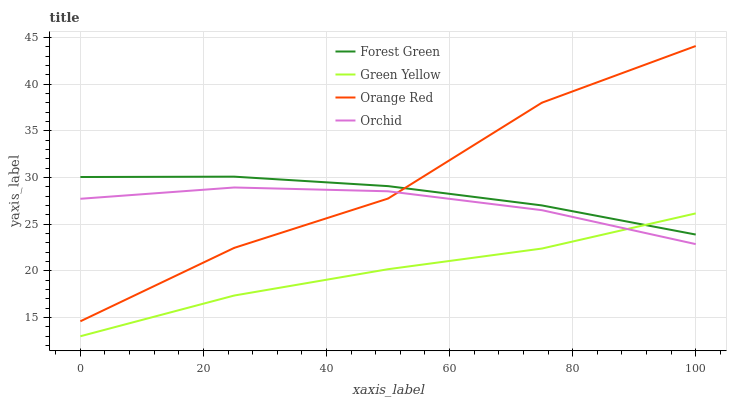Does Green Yellow have the minimum area under the curve?
Answer yes or no. Yes. Does Orange Red have the maximum area under the curve?
Answer yes or no. Yes. Does Orange Red have the minimum area under the curve?
Answer yes or no. No. Does Green Yellow have the maximum area under the curve?
Answer yes or no. No. Is Forest Green the smoothest?
Answer yes or no. Yes. Is Orange Red the roughest?
Answer yes or no. Yes. Is Green Yellow the smoothest?
Answer yes or no. No. Is Green Yellow the roughest?
Answer yes or no. No. Does Green Yellow have the lowest value?
Answer yes or no. Yes. Does Orange Red have the lowest value?
Answer yes or no. No. Does Orange Red have the highest value?
Answer yes or no. Yes. Does Green Yellow have the highest value?
Answer yes or no. No. Is Green Yellow less than Orange Red?
Answer yes or no. Yes. Is Orange Red greater than Green Yellow?
Answer yes or no. Yes. Does Forest Green intersect Orange Red?
Answer yes or no. Yes. Is Forest Green less than Orange Red?
Answer yes or no. No. Is Forest Green greater than Orange Red?
Answer yes or no. No. Does Green Yellow intersect Orange Red?
Answer yes or no. No. 